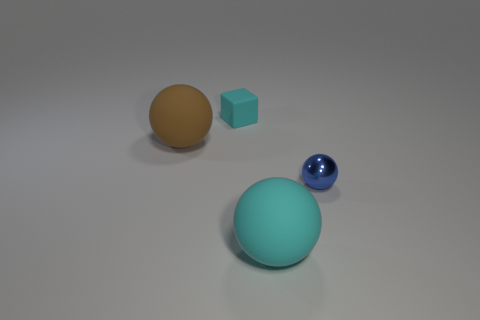Add 3 rubber blocks. How many objects exist? 7 Subtract 0 yellow balls. How many objects are left? 4 Subtract all balls. How many objects are left? 1 Subtract all blue spheres. Subtract all big matte things. How many objects are left? 1 Add 3 rubber spheres. How many rubber spheres are left? 5 Add 2 tiny matte cubes. How many tiny matte cubes exist? 3 